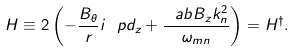Convert formula to latex. <formula><loc_0><loc_0><loc_500><loc_500>H \equiv 2 \left ( - \frac { B _ { \theta } } { r } i \ p d _ { z } + \frac { \ a b B _ { z } k _ { n } ^ { 2 } } { \omega _ { m n } } \right ) = H ^ { \dag } .</formula> 